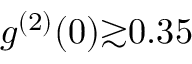Convert formula to latex. <formula><loc_0><loc_0><loc_500><loc_500>g ^ { ( 2 ) } ( 0 ) { \gtrsim } 0 . 3 5</formula> 